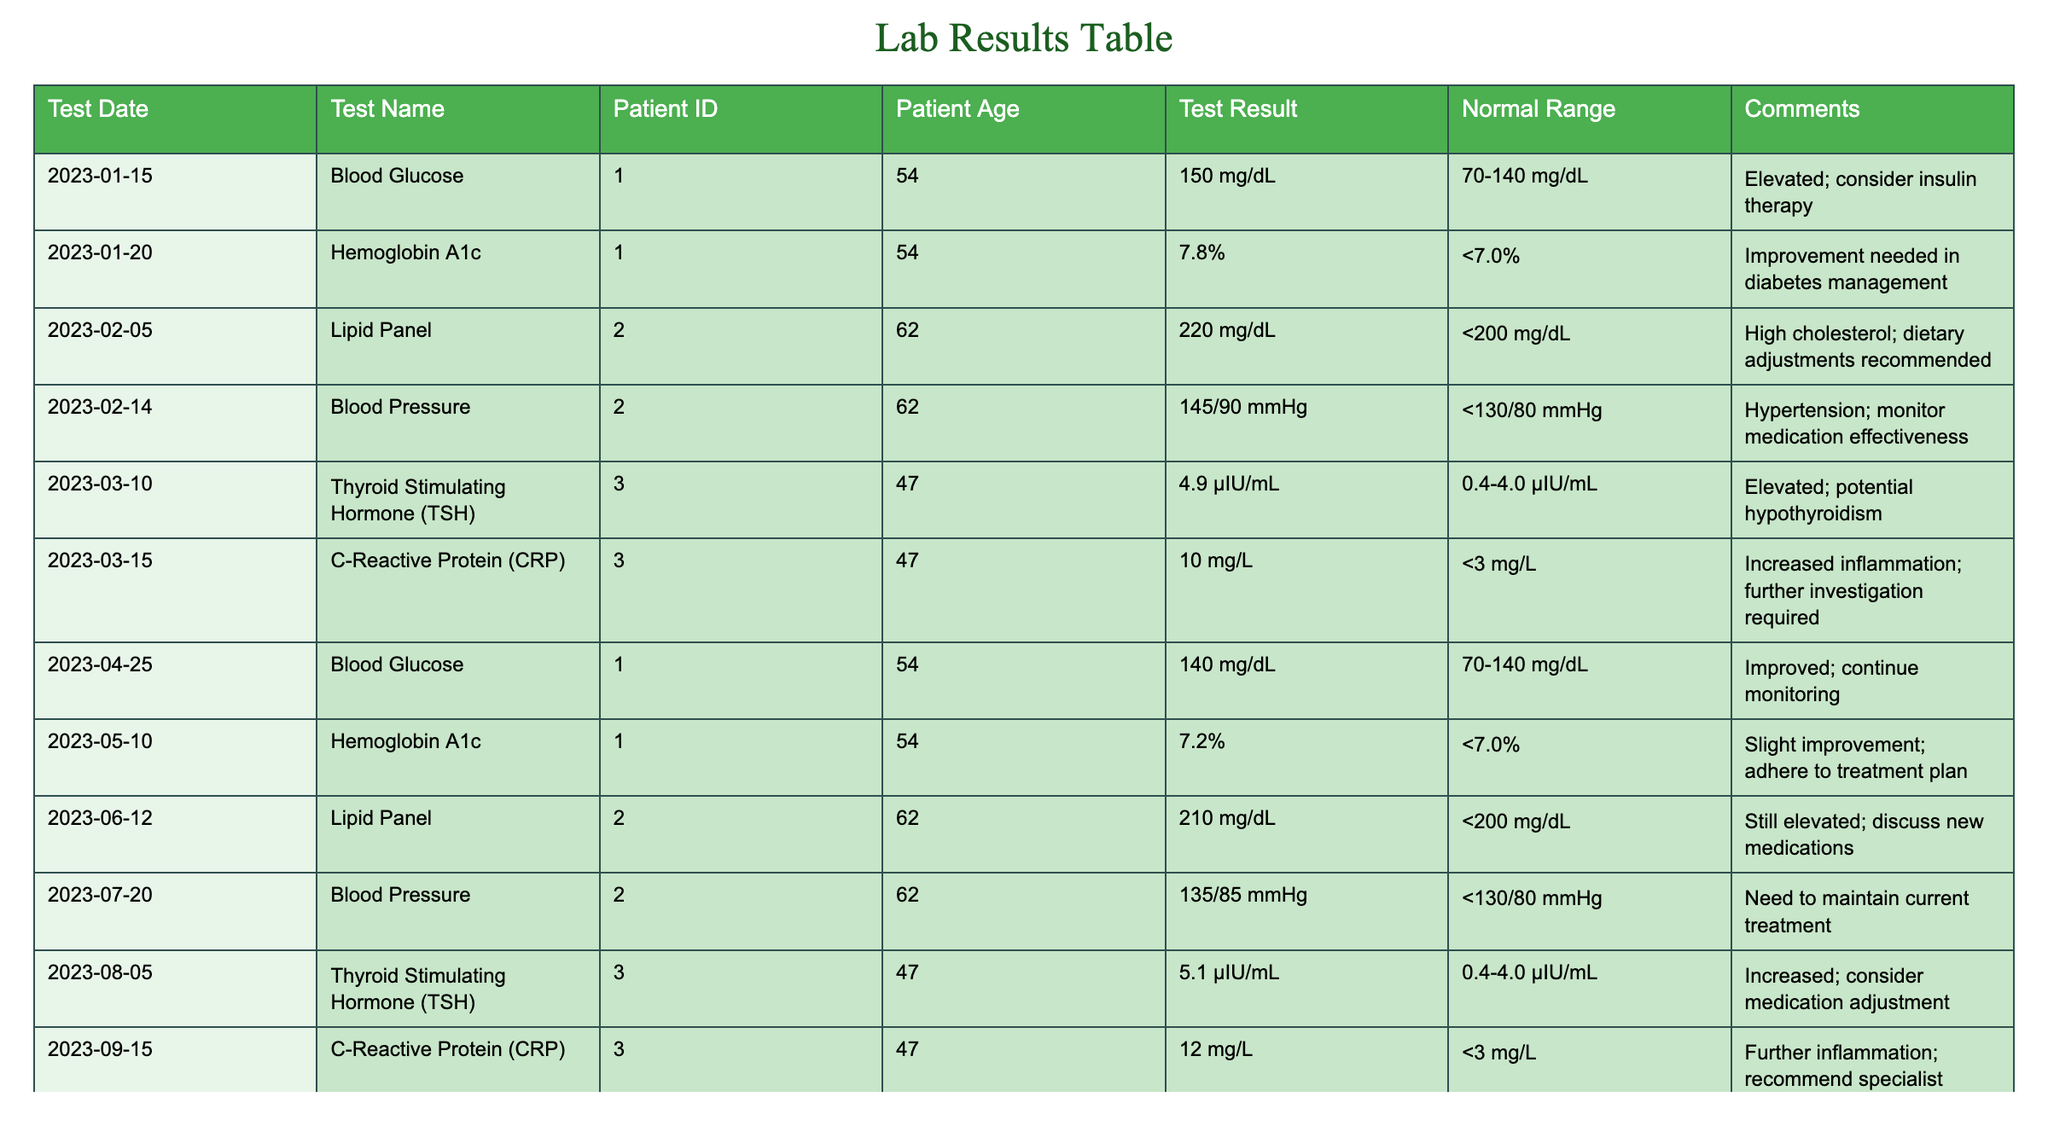What was the test result for Blood Glucose on January 15, 2023? The test result for Blood Glucose on January 15, 2023, is listed in the table as 150 mg/dL.
Answer: 150 mg/dL How many tests show elevated Hemoglobin A1c levels? There are two entries for Hemoglobin A1c: one on January 20, 2023, with a result of 7.8% and another on May 10, 2023, with a result of 7.2%. Both values are above the normal range of <7.0%, indicating two elevated levels.
Answer: 2 Is the patient with Patient ID 002 achieving normal results in their Blood Pressure tests? The Blood Pressure test results for Patient ID 002 include values of 145/90 mmHg on February 14, 2023, and 135/85 mmHg on July 20, 2023. Since both values exceed the normal range of <130/80 mmHg, the patient is not achieving normal results.
Answer: No What is the average Blood Glucose level for Patient ID 001 over the recorded tests? The Blood Glucose levels for Patient ID 001 are 150 mg/dL on January 15, 2023, 140 mg/dL on April 25, 2023, and 130 mg/dL on September 20, 2023. Summing these values gives 150 + 140 + 130 = 420 mg/dL. There are 3 tests, so the average is 420/3 = 140 mg/dL.
Answer: 140 mg/dL Did the CRP levels for Patient ID 003 improve over the year? The CRP levels for Patient ID 003 were 10 mg/L on March 15, 2023, and 12 mg/L on September 15, 2023. Since the latter value is higher than the former, indicating a worsening of the condition, it can be concluded that there was no improvement.
Answer: No 